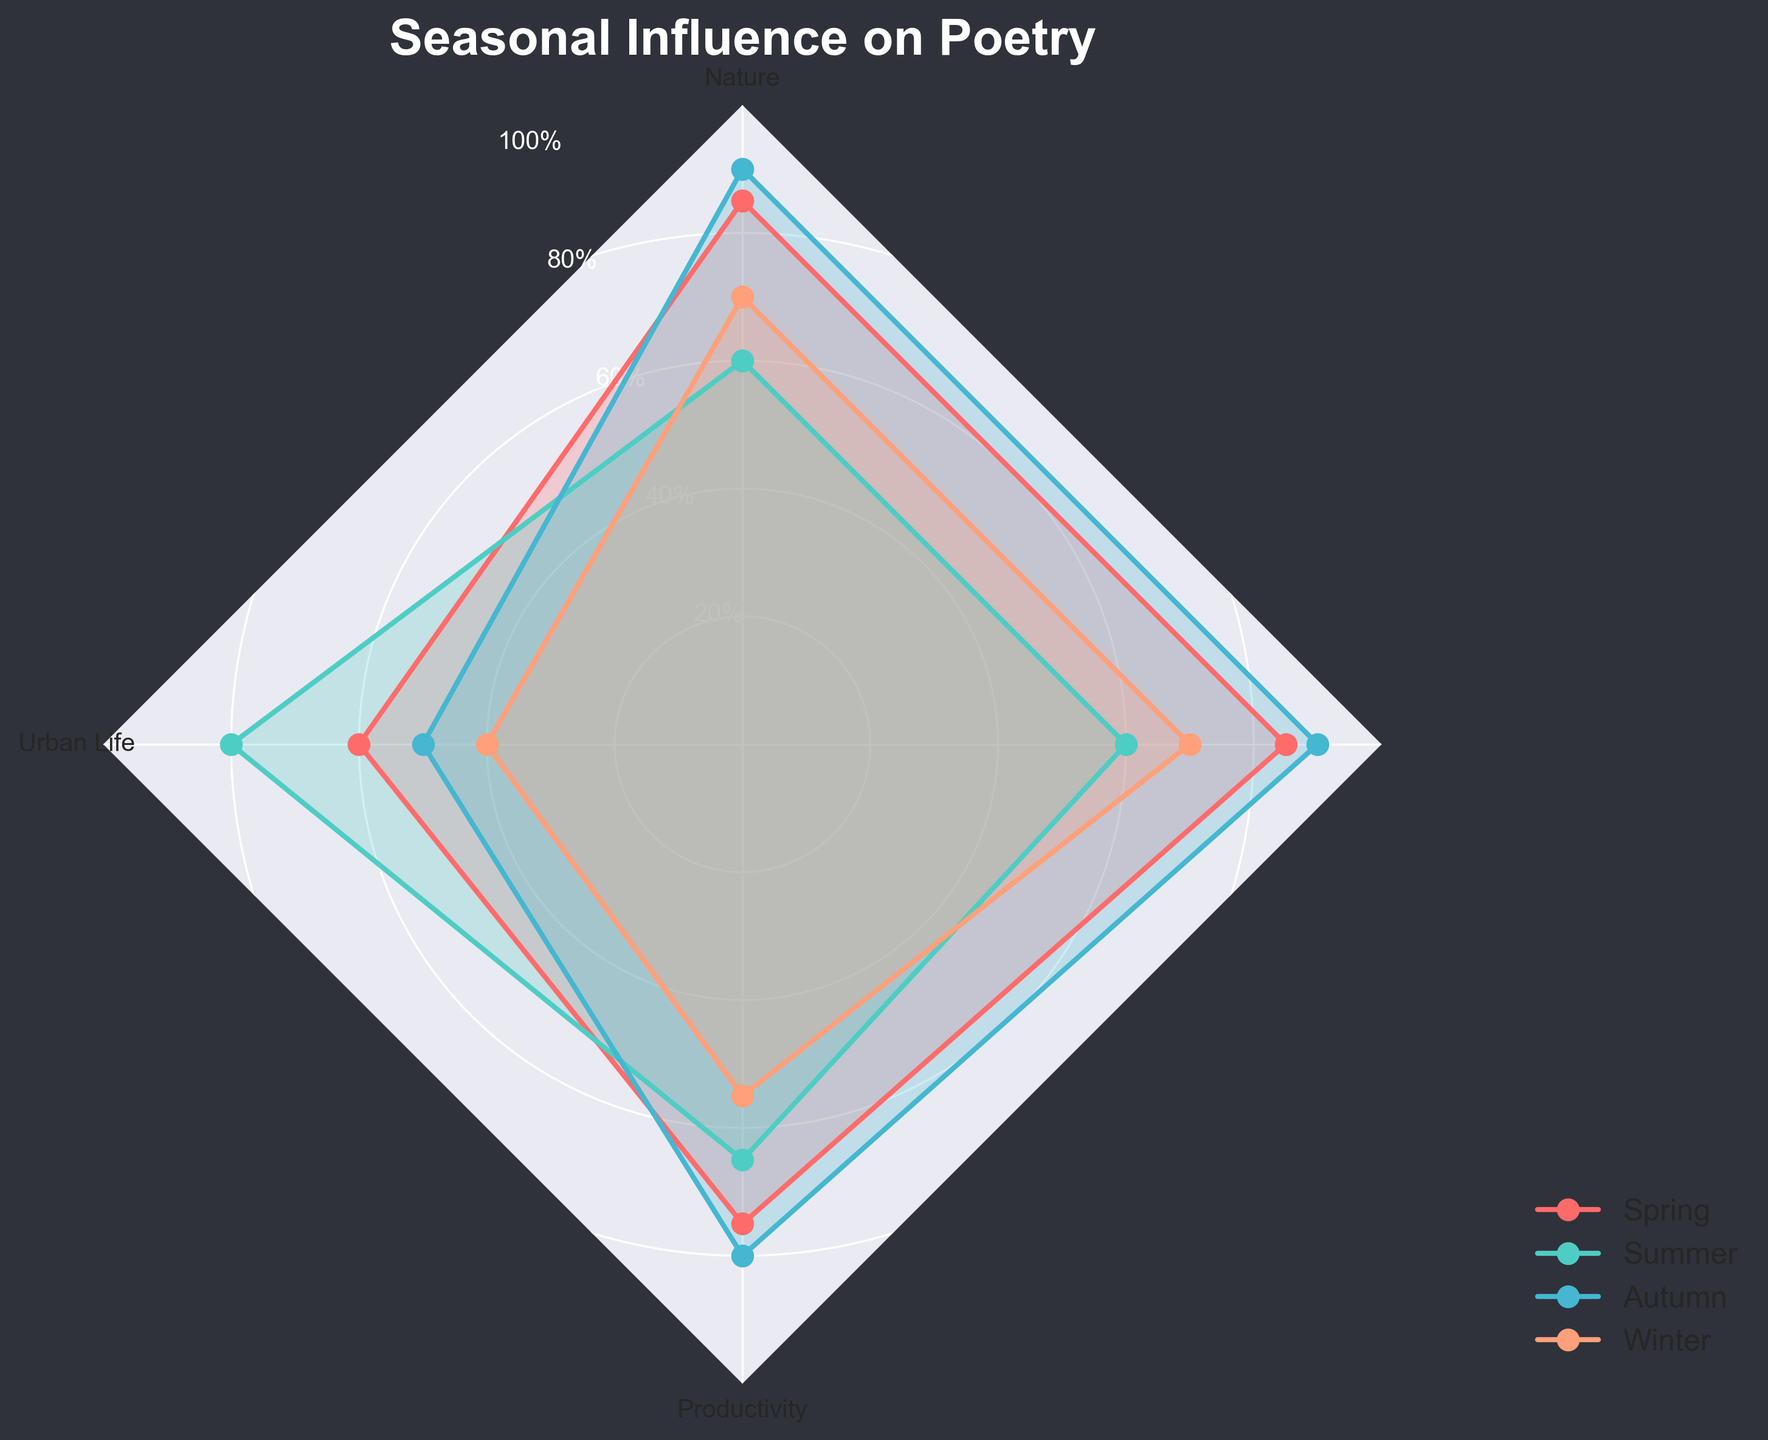What is the title of the figure? The title is at the top, usually in a larger font size, and often in bold. Here, it reads "Seasonal Influence on Poetry".
Answer: Seasonal Influence on Poetry What are the four seasons displayed in the chart? The seasons are labeled in the legend, positioned near the bottom right of the figure. The seasons listed are Spring, Summer, Autumn, and Winter.
Answer: Spring, Summer, Autumn, Winter Which season has the highest writing productivity? Writing productivity is one of the axes of the radar chart. By following each season's line to the productivity axis, it's clear that Autumn has the highest value for writing productivity.
Answer: Autumn How does inspiration from nature compare between Spring and Summer? To compare, we look at the position of Spring and Summer on the 'Nature' axis. Spring has a value of 85, while Summer has a value of 60, indicating that Spring has higher inspiration from nature.
Answer: Spring has higher inspiration from nature than Summer What season has the lowest inspiration from urban life? The 'Urban Life' axis shows different values for each season. By looking at each, Winter has the lowest value at 40.
Answer: Winter Rank the seasons from highest to lowest in terms of inspiration from nature. Look at the 'Nature' axis and note the values for each season: Autumn (90), Spring (85), Winter (70), and Summer (60). So, the rank from highest to lowest is Autumn, Spring, Winter, and Summer.
Answer: Autumn, Spring, Winter, Summer Which season shows the greatest difference between inspiration from nature and inspiration from urban life? Calculate the difference between 'Nature' and 'Urban Life' for each season: Spring (85-60=25), Summer (60-80=-20), Autumn (90-50=40), Winter (70-40=30). Autumn has the greatest difference of 40.
Answer: Autumn Compare the overall pattern for Winter in terms of Nature, Urban Life, and Productivity. For Winter, the values are 70 for Nature, 40 for Urban Life, and 55 for Productivity. This shows that Winter has moderate inspiration from Nature, low inspiration from Urban Life, and moderate writing productivity.
Answer: Winter: 70 Nature, 40 Urban Life, 55 Productivity 